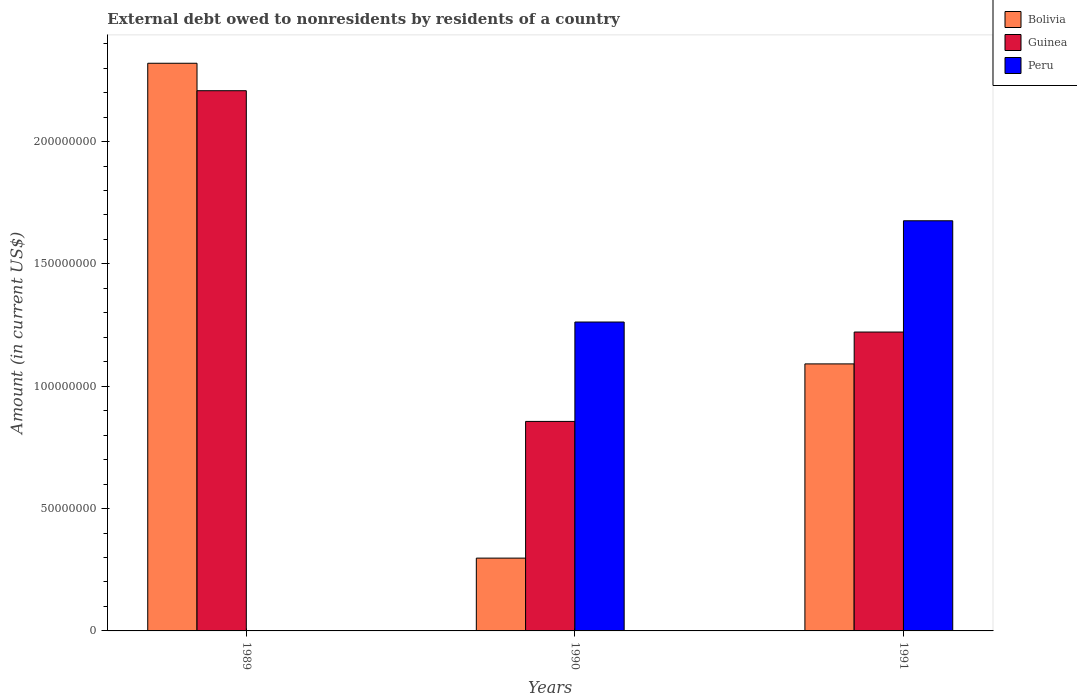Are the number of bars per tick equal to the number of legend labels?
Provide a succinct answer. No. Are the number of bars on each tick of the X-axis equal?
Offer a terse response. No. How many bars are there on the 3rd tick from the left?
Provide a succinct answer. 3. How many bars are there on the 3rd tick from the right?
Ensure brevity in your answer.  2. What is the label of the 2nd group of bars from the left?
Your answer should be compact. 1990. What is the external debt owed by residents in Bolivia in 1989?
Provide a succinct answer. 2.32e+08. Across all years, what is the maximum external debt owed by residents in Guinea?
Your response must be concise. 2.21e+08. Across all years, what is the minimum external debt owed by residents in Guinea?
Provide a succinct answer. 8.56e+07. In which year was the external debt owed by residents in Guinea maximum?
Offer a very short reply. 1989. What is the total external debt owed by residents in Peru in the graph?
Keep it short and to the point. 2.94e+08. What is the difference between the external debt owed by residents in Bolivia in 1989 and that in 1990?
Offer a very short reply. 2.02e+08. What is the difference between the external debt owed by residents in Peru in 1991 and the external debt owed by residents in Bolivia in 1990?
Your response must be concise. 1.38e+08. What is the average external debt owed by residents in Guinea per year?
Ensure brevity in your answer.  1.43e+08. In the year 1991, what is the difference between the external debt owed by residents in Peru and external debt owed by residents in Bolivia?
Give a very brief answer. 5.85e+07. In how many years, is the external debt owed by residents in Bolivia greater than 70000000 US$?
Offer a very short reply. 2. What is the ratio of the external debt owed by residents in Bolivia in 1989 to that in 1990?
Your answer should be very brief. 7.8. Is the external debt owed by residents in Guinea in 1989 less than that in 1991?
Offer a terse response. No. Is the difference between the external debt owed by residents in Peru in 1990 and 1991 greater than the difference between the external debt owed by residents in Bolivia in 1990 and 1991?
Keep it short and to the point. Yes. What is the difference between the highest and the second highest external debt owed by residents in Bolivia?
Offer a terse response. 1.23e+08. What is the difference between the highest and the lowest external debt owed by residents in Peru?
Provide a short and direct response. 1.68e+08. In how many years, is the external debt owed by residents in Peru greater than the average external debt owed by residents in Peru taken over all years?
Keep it short and to the point. 2. Is the sum of the external debt owed by residents in Bolivia in 1990 and 1991 greater than the maximum external debt owed by residents in Peru across all years?
Your answer should be very brief. No. How many bars are there?
Offer a terse response. 8. Does the graph contain grids?
Your response must be concise. No. How many legend labels are there?
Provide a short and direct response. 3. How are the legend labels stacked?
Your response must be concise. Vertical. What is the title of the graph?
Your answer should be compact. External debt owed to nonresidents by residents of a country. Does "Greenland" appear as one of the legend labels in the graph?
Keep it short and to the point. No. What is the label or title of the X-axis?
Your response must be concise. Years. What is the Amount (in current US$) in Bolivia in 1989?
Your response must be concise. 2.32e+08. What is the Amount (in current US$) in Guinea in 1989?
Keep it short and to the point. 2.21e+08. What is the Amount (in current US$) in Bolivia in 1990?
Your answer should be compact. 2.98e+07. What is the Amount (in current US$) of Guinea in 1990?
Provide a short and direct response. 8.56e+07. What is the Amount (in current US$) in Peru in 1990?
Ensure brevity in your answer.  1.26e+08. What is the Amount (in current US$) of Bolivia in 1991?
Your answer should be very brief. 1.09e+08. What is the Amount (in current US$) of Guinea in 1991?
Offer a terse response. 1.22e+08. What is the Amount (in current US$) of Peru in 1991?
Keep it short and to the point. 1.68e+08. Across all years, what is the maximum Amount (in current US$) of Bolivia?
Provide a short and direct response. 2.32e+08. Across all years, what is the maximum Amount (in current US$) in Guinea?
Ensure brevity in your answer.  2.21e+08. Across all years, what is the maximum Amount (in current US$) in Peru?
Keep it short and to the point. 1.68e+08. Across all years, what is the minimum Amount (in current US$) in Bolivia?
Ensure brevity in your answer.  2.98e+07. Across all years, what is the minimum Amount (in current US$) in Guinea?
Offer a terse response. 8.56e+07. Across all years, what is the minimum Amount (in current US$) in Peru?
Offer a very short reply. 0. What is the total Amount (in current US$) of Bolivia in the graph?
Ensure brevity in your answer.  3.71e+08. What is the total Amount (in current US$) of Guinea in the graph?
Give a very brief answer. 4.29e+08. What is the total Amount (in current US$) in Peru in the graph?
Ensure brevity in your answer.  2.94e+08. What is the difference between the Amount (in current US$) of Bolivia in 1989 and that in 1990?
Make the answer very short. 2.02e+08. What is the difference between the Amount (in current US$) of Guinea in 1989 and that in 1990?
Keep it short and to the point. 1.35e+08. What is the difference between the Amount (in current US$) in Bolivia in 1989 and that in 1991?
Ensure brevity in your answer.  1.23e+08. What is the difference between the Amount (in current US$) of Guinea in 1989 and that in 1991?
Make the answer very short. 9.86e+07. What is the difference between the Amount (in current US$) in Bolivia in 1990 and that in 1991?
Offer a terse response. -7.94e+07. What is the difference between the Amount (in current US$) of Guinea in 1990 and that in 1991?
Ensure brevity in your answer.  -3.65e+07. What is the difference between the Amount (in current US$) of Peru in 1990 and that in 1991?
Make the answer very short. -4.14e+07. What is the difference between the Amount (in current US$) of Bolivia in 1989 and the Amount (in current US$) of Guinea in 1990?
Your answer should be compact. 1.46e+08. What is the difference between the Amount (in current US$) of Bolivia in 1989 and the Amount (in current US$) of Peru in 1990?
Provide a short and direct response. 1.06e+08. What is the difference between the Amount (in current US$) of Guinea in 1989 and the Amount (in current US$) of Peru in 1990?
Provide a short and direct response. 9.45e+07. What is the difference between the Amount (in current US$) of Bolivia in 1989 and the Amount (in current US$) of Guinea in 1991?
Make the answer very short. 1.10e+08. What is the difference between the Amount (in current US$) in Bolivia in 1989 and the Amount (in current US$) in Peru in 1991?
Offer a terse response. 6.44e+07. What is the difference between the Amount (in current US$) of Guinea in 1989 and the Amount (in current US$) of Peru in 1991?
Make the answer very short. 5.32e+07. What is the difference between the Amount (in current US$) of Bolivia in 1990 and the Amount (in current US$) of Guinea in 1991?
Your response must be concise. -9.24e+07. What is the difference between the Amount (in current US$) of Bolivia in 1990 and the Amount (in current US$) of Peru in 1991?
Give a very brief answer. -1.38e+08. What is the difference between the Amount (in current US$) of Guinea in 1990 and the Amount (in current US$) of Peru in 1991?
Provide a succinct answer. -8.20e+07. What is the average Amount (in current US$) in Bolivia per year?
Keep it short and to the point. 1.24e+08. What is the average Amount (in current US$) in Guinea per year?
Offer a very short reply. 1.43e+08. What is the average Amount (in current US$) in Peru per year?
Your response must be concise. 9.80e+07. In the year 1989, what is the difference between the Amount (in current US$) in Bolivia and Amount (in current US$) in Guinea?
Offer a terse response. 1.12e+07. In the year 1990, what is the difference between the Amount (in current US$) in Bolivia and Amount (in current US$) in Guinea?
Provide a short and direct response. -5.59e+07. In the year 1990, what is the difference between the Amount (in current US$) of Bolivia and Amount (in current US$) of Peru?
Provide a short and direct response. -9.65e+07. In the year 1990, what is the difference between the Amount (in current US$) in Guinea and Amount (in current US$) in Peru?
Your answer should be compact. -4.06e+07. In the year 1991, what is the difference between the Amount (in current US$) in Bolivia and Amount (in current US$) in Guinea?
Offer a very short reply. -1.30e+07. In the year 1991, what is the difference between the Amount (in current US$) of Bolivia and Amount (in current US$) of Peru?
Your answer should be compact. -5.85e+07. In the year 1991, what is the difference between the Amount (in current US$) in Guinea and Amount (in current US$) in Peru?
Your answer should be compact. -4.55e+07. What is the ratio of the Amount (in current US$) in Bolivia in 1989 to that in 1990?
Provide a succinct answer. 7.8. What is the ratio of the Amount (in current US$) in Guinea in 1989 to that in 1990?
Your response must be concise. 2.58. What is the ratio of the Amount (in current US$) of Bolivia in 1989 to that in 1991?
Give a very brief answer. 2.13. What is the ratio of the Amount (in current US$) of Guinea in 1989 to that in 1991?
Offer a terse response. 1.81. What is the ratio of the Amount (in current US$) in Bolivia in 1990 to that in 1991?
Provide a succinct answer. 0.27. What is the ratio of the Amount (in current US$) of Guinea in 1990 to that in 1991?
Your answer should be very brief. 0.7. What is the ratio of the Amount (in current US$) in Peru in 1990 to that in 1991?
Offer a terse response. 0.75. What is the difference between the highest and the second highest Amount (in current US$) of Bolivia?
Provide a succinct answer. 1.23e+08. What is the difference between the highest and the second highest Amount (in current US$) of Guinea?
Offer a very short reply. 9.86e+07. What is the difference between the highest and the lowest Amount (in current US$) in Bolivia?
Offer a very short reply. 2.02e+08. What is the difference between the highest and the lowest Amount (in current US$) of Guinea?
Your answer should be compact. 1.35e+08. What is the difference between the highest and the lowest Amount (in current US$) in Peru?
Give a very brief answer. 1.68e+08. 